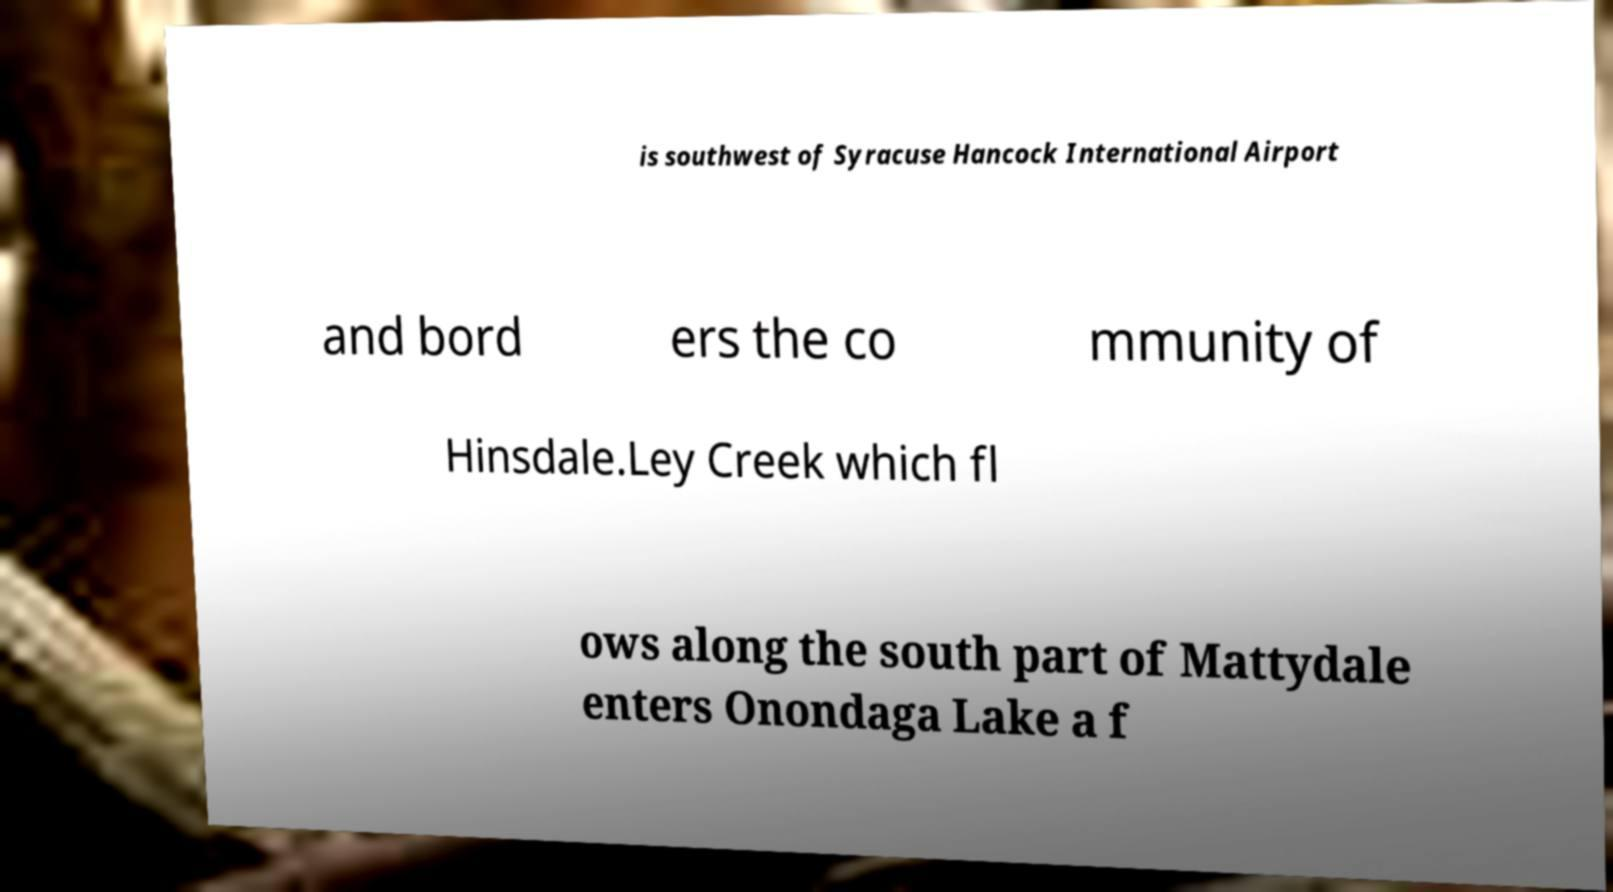Could you extract and type out the text from this image? is southwest of Syracuse Hancock International Airport and bord ers the co mmunity of Hinsdale.Ley Creek which fl ows along the south part of Mattydale enters Onondaga Lake a f 